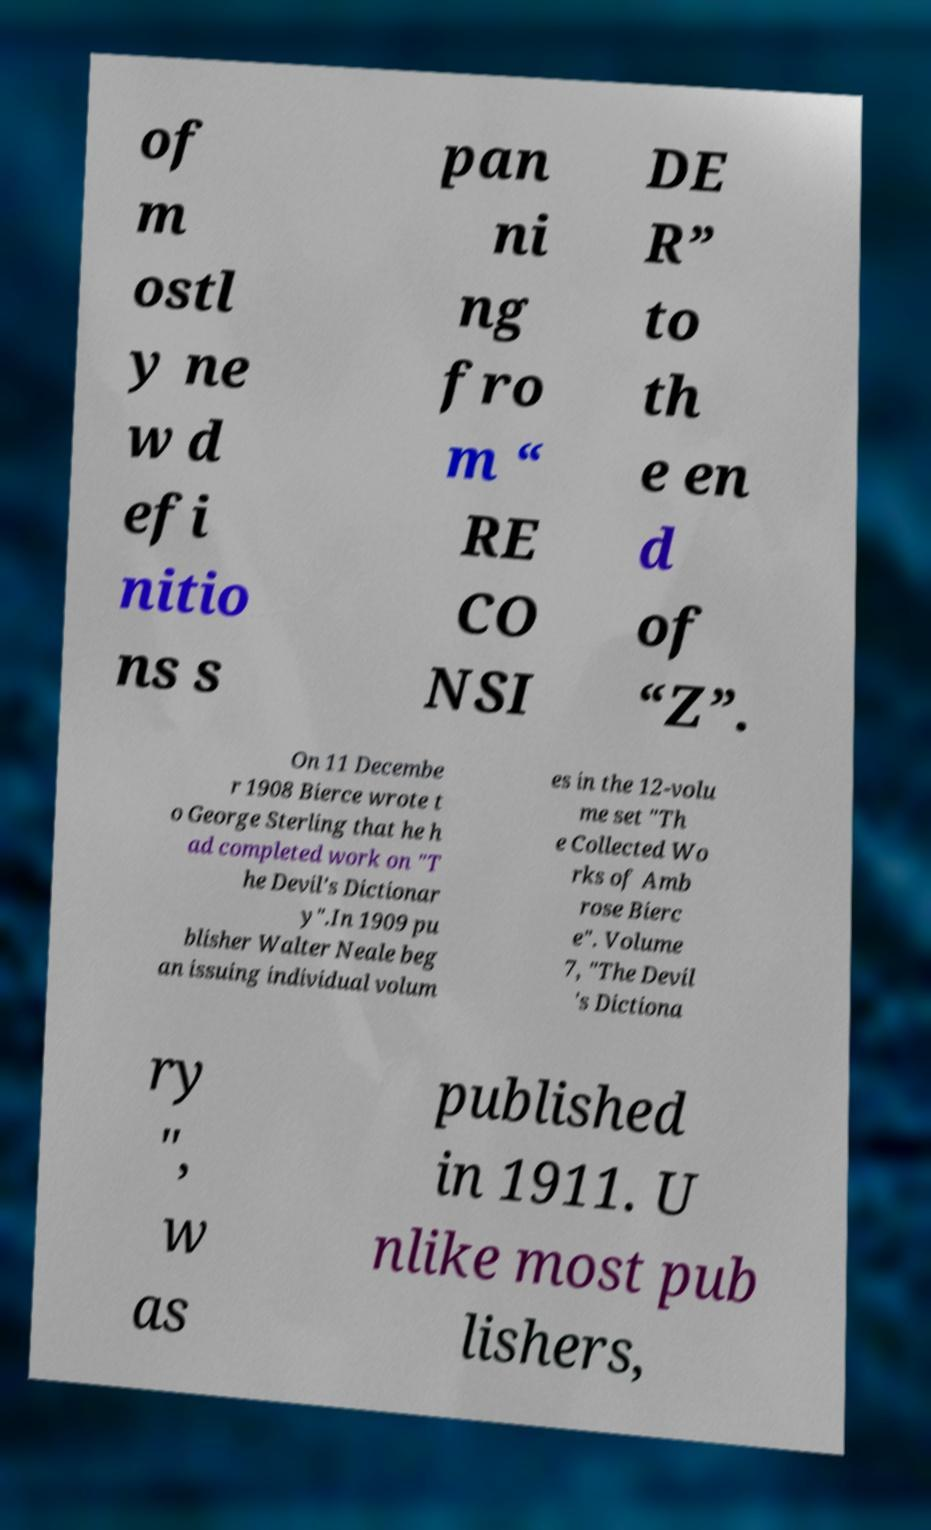For documentation purposes, I need the text within this image transcribed. Could you provide that? of m ostl y ne w d efi nitio ns s pan ni ng fro m “ RE CO NSI DE R” to th e en d of “Z”. On 11 Decembe r 1908 Bierce wrote t o George Sterling that he h ad completed work on "T he Devil's Dictionar y".In 1909 pu blisher Walter Neale beg an issuing individual volum es in the 12-volu me set "Th e Collected Wo rks of Amb rose Bierc e". Volume 7, "The Devil 's Dictiona ry ", w as published in 1911. U nlike most pub lishers, 